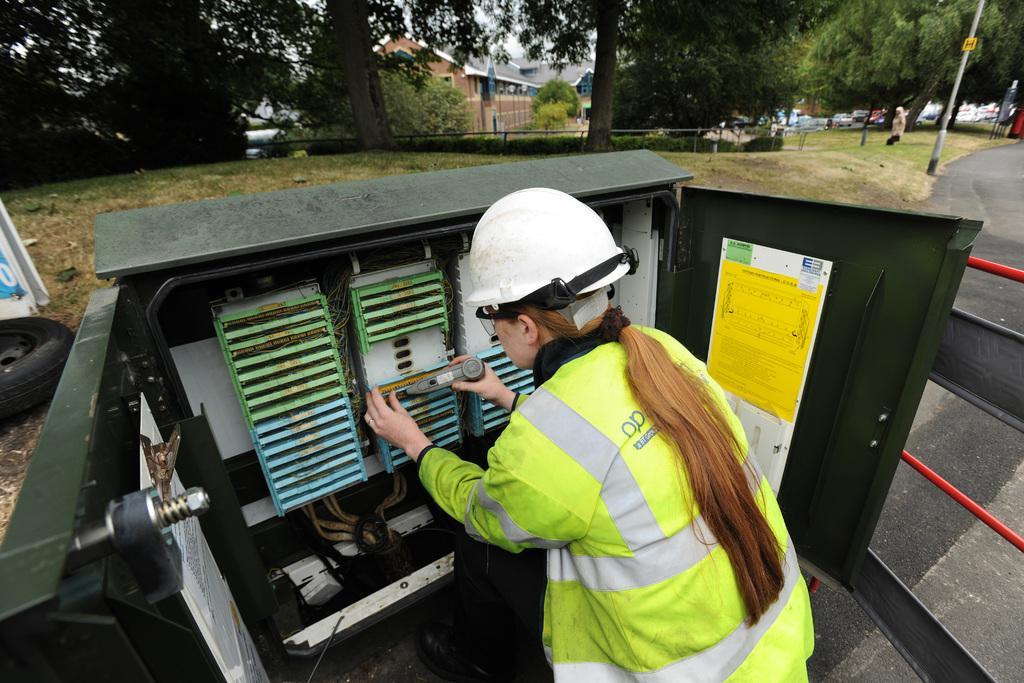Can you describe this image briefly? In the foreground I can see a woman, metal box and a fence. In the background I can see a tire, grass, trees, poles, group of people, vehicles and buildings. This image is taken may be during a day. 